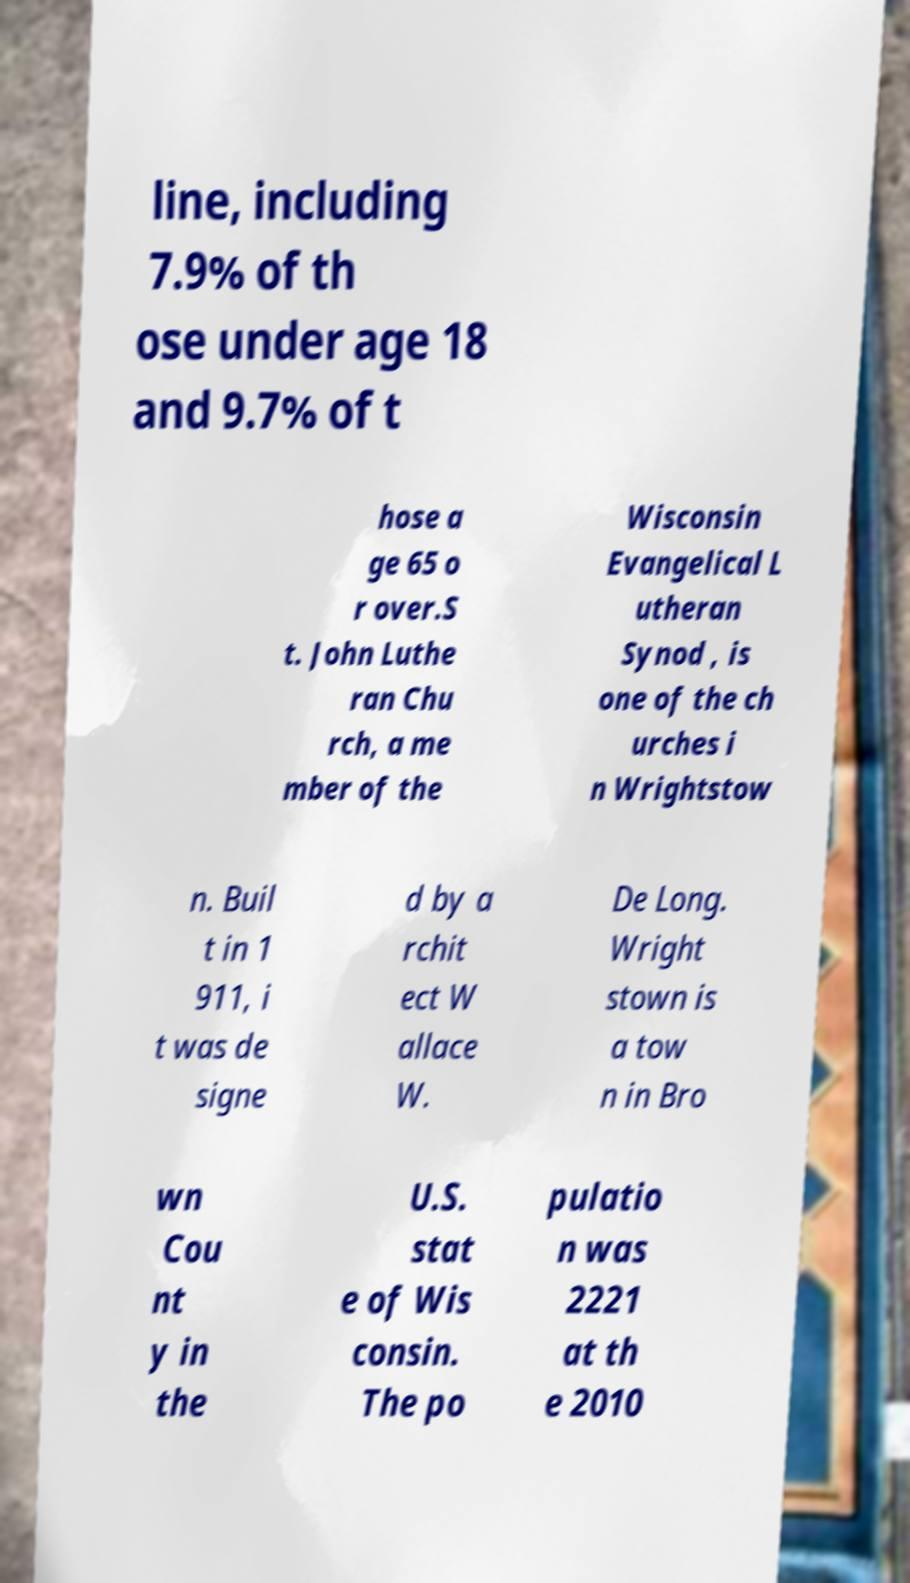What messages or text are displayed in this image? I need them in a readable, typed format. line, including 7.9% of th ose under age 18 and 9.7% of t hose a ge 65 o r over.S t. John Luthe ran Chu rch, a me mber of the Wisconsin Evangelical L utheran Synod , is one of the ch urches i n Wrightstow n. Buil t in 1 911, i t was de signe d by a rchit ect W allace W. De Long. Wright stown is a tow n in Bro wn Cou nt y in the U.S. stat e of Wis consin. The po pulatio n was 2221 at th e 2010 